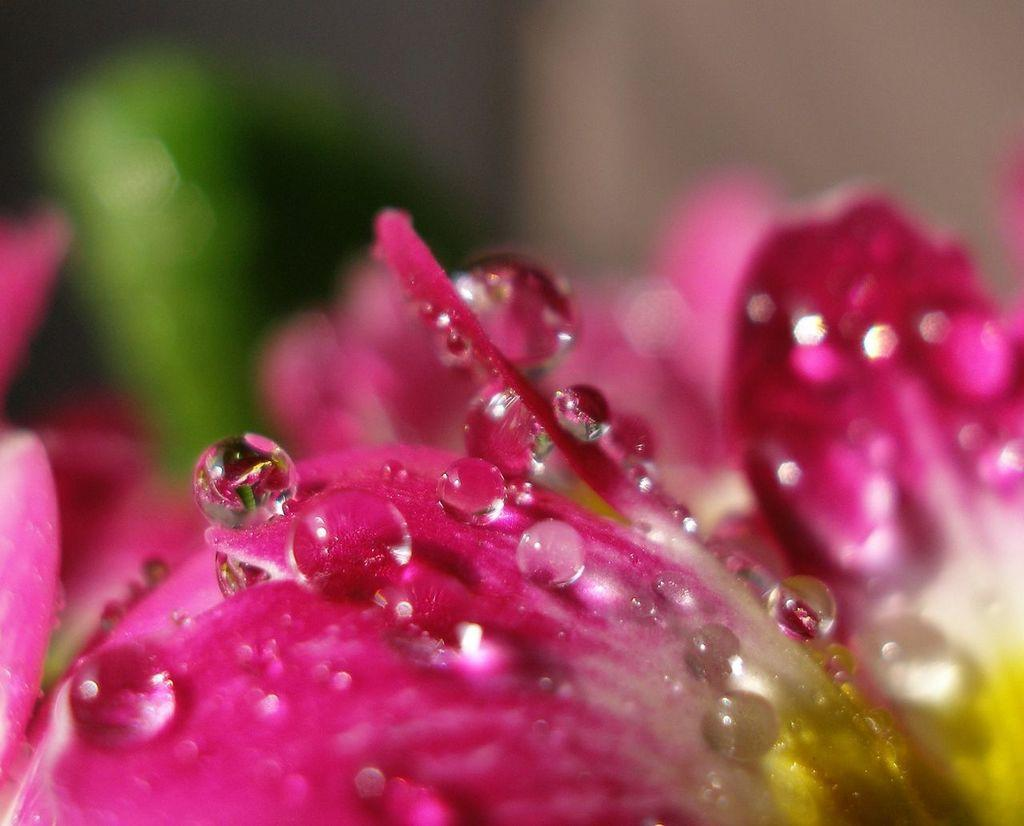What is the main subject of the image? There is a close view of a flower in the image. Can you describe any specific details about the flower? The flower has water droplets on it. How would you describe the background of the image? The background of the image is slightly blurred. Reasoning: Let's think step by following the guidelines to produce the conversation. We start by identifying the main subject of the image, which is the flower. Then, we describe specific details about the flower, such as the presence of water droplets. Finally, we mention the background of the image, noting that it is slightly blurred. We avoid yes/no questions and ensure that the language is simple and clear. Absurd Question/Answer: What is the weight of the father's memory in the image? There is no father or memory present in the image; it features a close view of a flower with water droplets and a slightly blurred background. What is the weight of the father's memory in the image? There is no father or memory present in the image; it features a close view of a flower with water droplets and a slightly blurred background. 